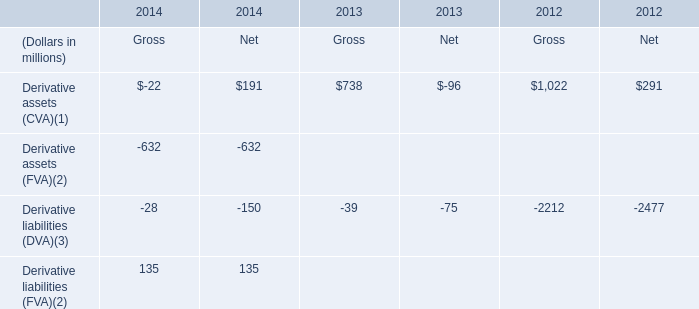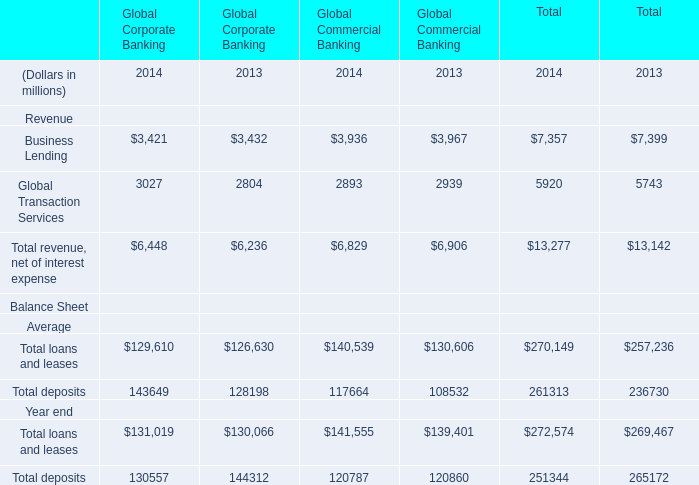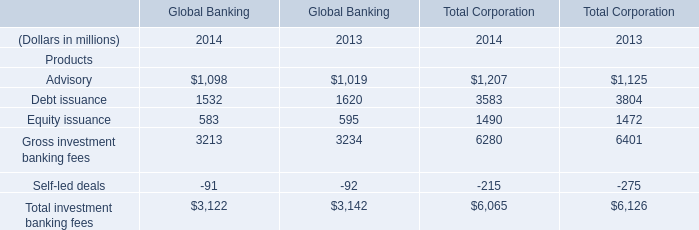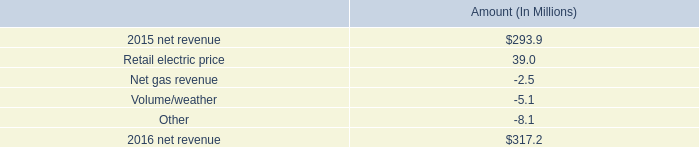How many elements show negative value in 2014 forGlobal Banking ? 
Answer: 1. 